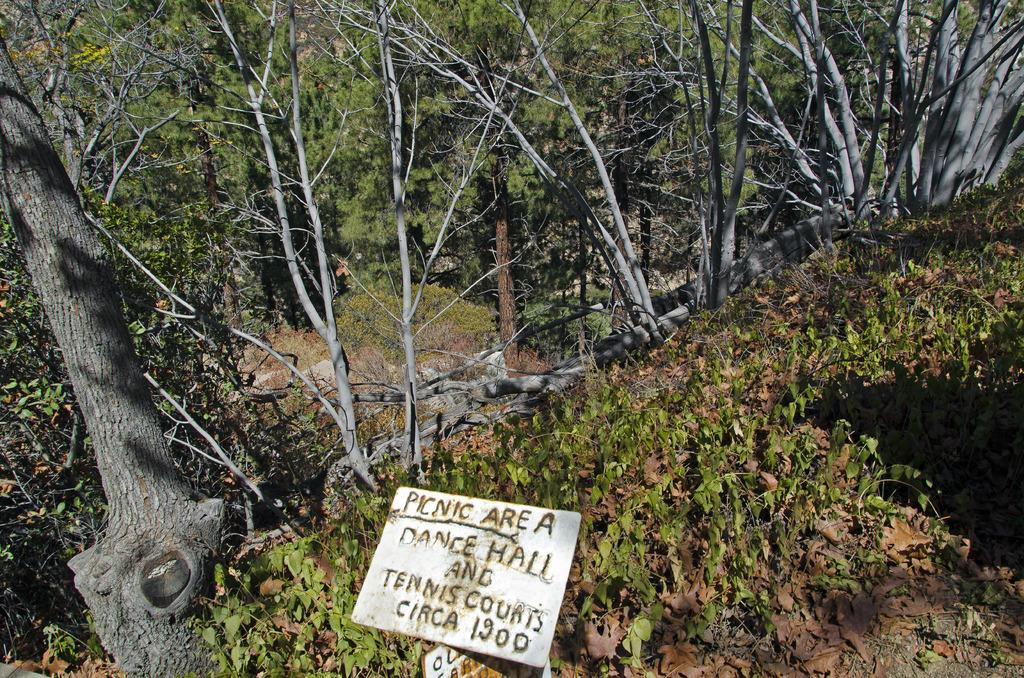What is located at the bottom of the image? There is a board at the bottom of the image. What can be seen in the background of the image? There are trees, plants, and grass in the background of the image. How many drawers are visible in the image? There are no drawers present in the image. What type of cast can be seen on the person in the image? There is no person or cast visible in the image. 